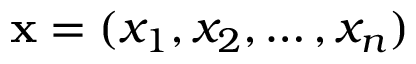<formula> <loc_0><loc_0><loc_500><loc_500>x = ( x _ { 1 } , x _ { 2 } , \dots , x _ { n } )</formula> 